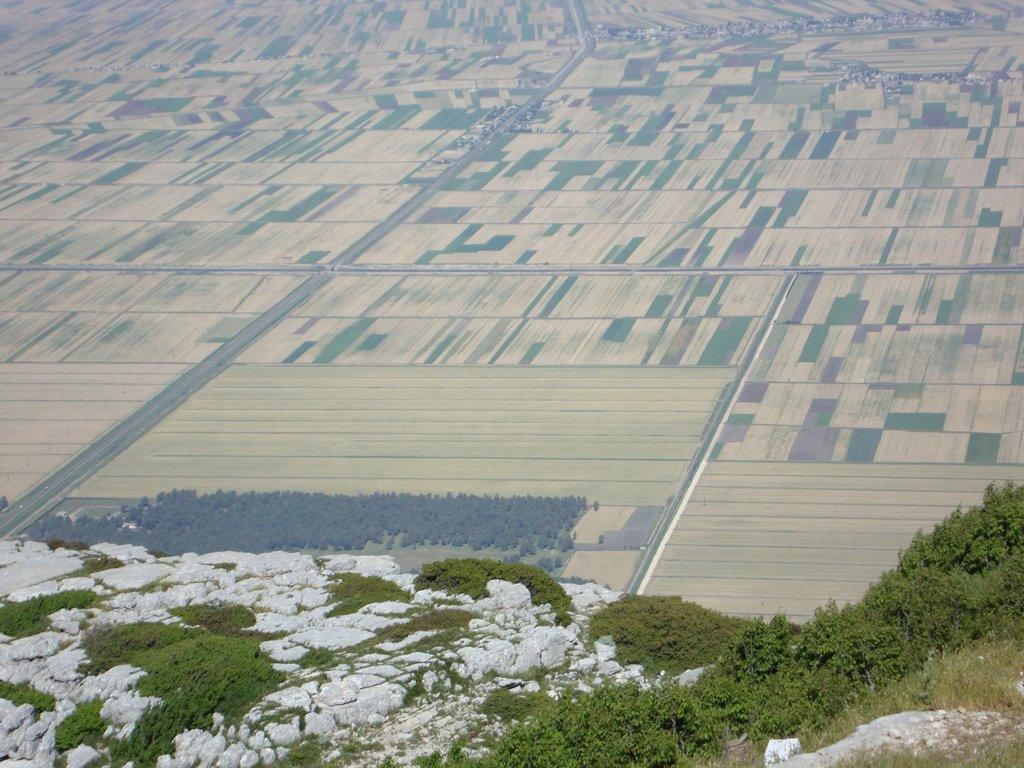What type of vegetation can be seen in the image? There are plants in the image. What can be seen on the mountain in the image? There is grass on the mountain in the image. What is visible in the background of the image? There is ground, trees, and a road visible in the background of the image. How many legs can be seen on the plants in the image? Plants do not have legs, so this question cannot be answered based on the image. 